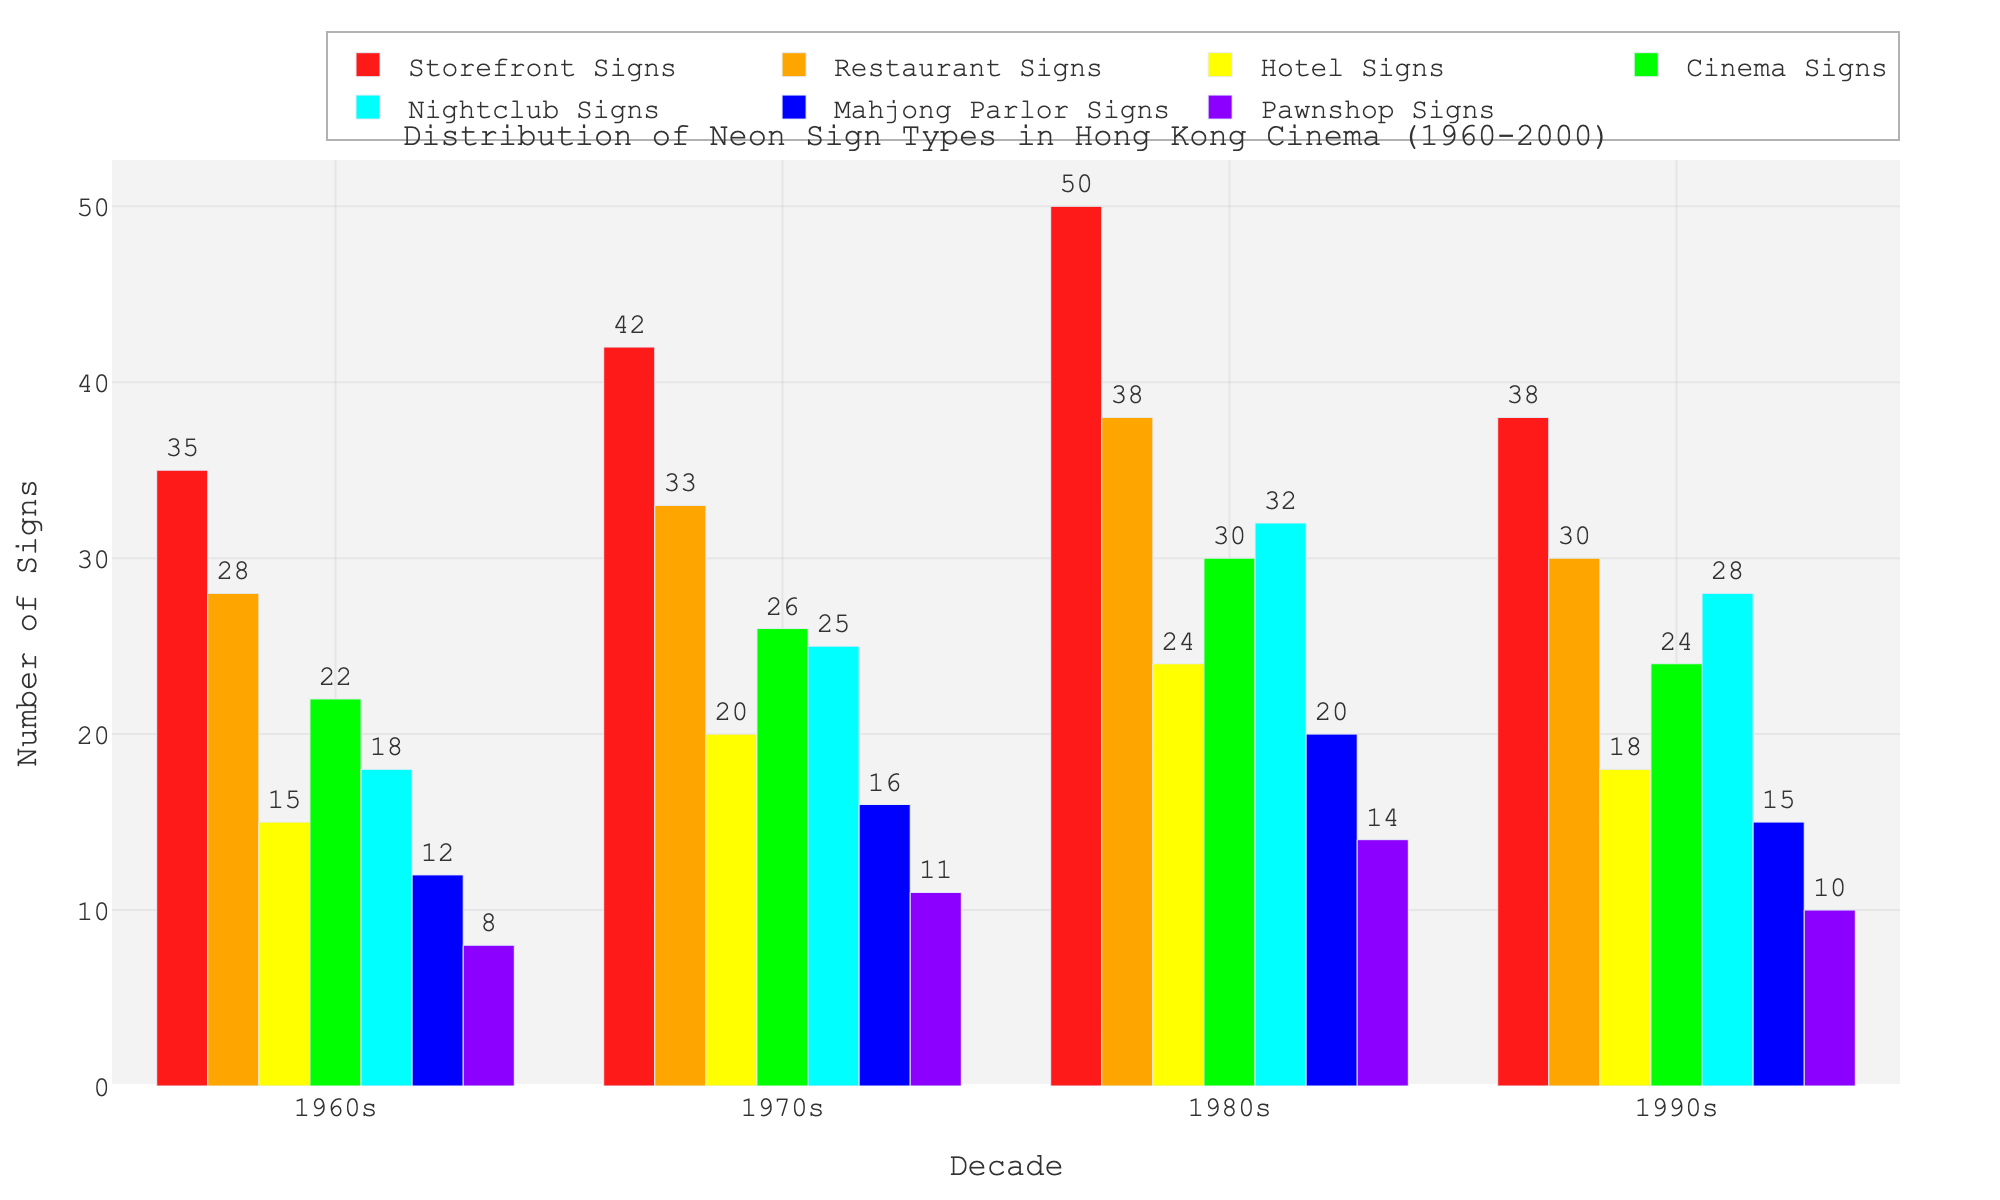Which decade had the highest number of Restaurant Signs? In the chart, observe the Restaurant Signs category for each decade and note their heights. The 1980s bar is the tallest among the decades.
Answer: 1980s During which decade did Nightclub Signs see the greatest increase compared to the previous decade? Look at the difference in the heights of the Nightclub Signs bars between each consecutive decade. The jump from the 1970s to the 1980s is the greatest.
Answer: 1980s What is the average number of Storefront Signs displayed over all decades? Sum up the number of Storefront Signs for each decade (35 + 42 + 50 + 38 = 165) and divide by the number of decades (4).
Answer: 41.25 Which neon sign type was consistently lowest in number during all decades? Compare the heights of the bars for each sign type in each decade. The Pawnshop Signs category consistently has the lowest heights.
Answer: Pawnshop Signs How did the number of Mahjong Parlor Signs change from the 1960s to the 1990s? Identify the Mahjong Parlor Signs figures for these years (12 in the 1960s and 15 in the 1990s) and calculate the difference (15 - 12 = 3).
Answer: Increased by 3 Which type of neon sign had the largest total count over all decades? Sum the counts of each neon sign type across all decades and compare. Storefront Signs have the highest total (35+42+50+38=165).
Answer: Storefront Signs Between the 1970s and 1980s, which neon sign type saw the greatest absolute increase? Calculate the differences between the counts from the 1970s and 1980s for each type. Nightclub Signs increased from 25 to 32, the largest difference (32-25=7).
Answer: Nightclub Signs Were Hotel Signs more common in the 1990s or Restaurant Signs in the 1960s? Compare the heights of the Hotel Signs bar in the 1990s (18) and the Restaurant Signs bar in the 1960s (28).
Answer: Restaurant Signs in the 1960s What's the total number of Cinema Signs counted from 1960 to 2000? Sum the counts of Cinema Signs for each decade (22+26+30+24=102).
Answer: 102 